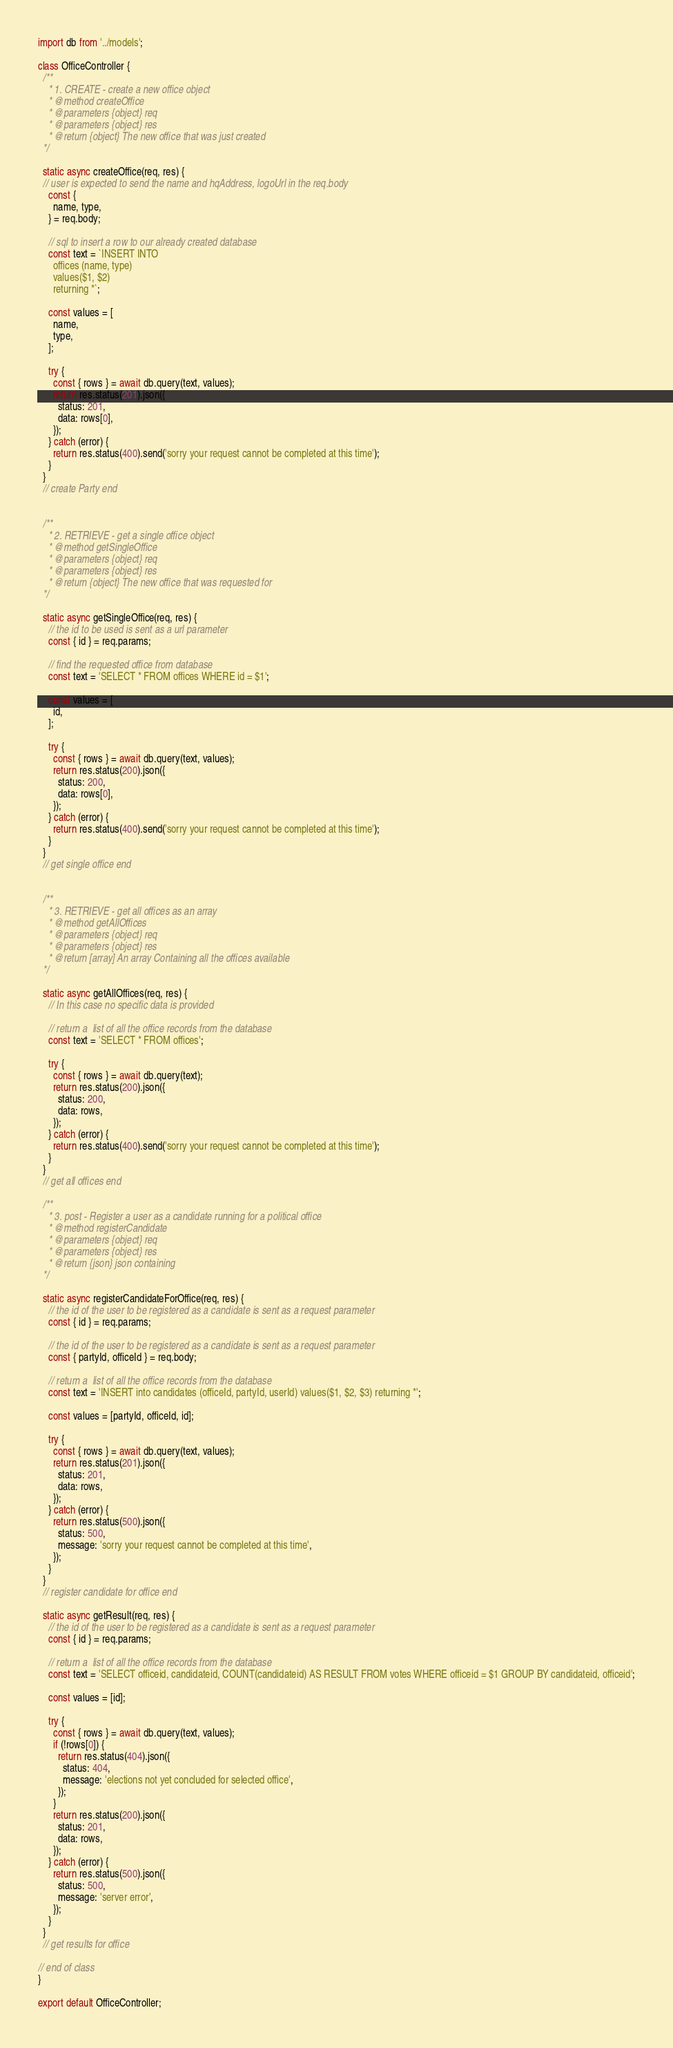Convert code to text. <code><loc_0><loc_0><loc_500><loc_500><_JavaScript_>import db from '../models';

class OfficeController {
  /**
    * 1. CREATE - create a new office object
    * @method createOffice
    * @parameters {object} req
    * @parameters {object} res
    * @return {object} The new office that was just created
  */

  static async createOffice(req, res) {
  // user is expected to send the name and hqAddress, logoUrl in the req.body
    const {
      name, type,
    } = req.body;

    // sql to insert a row to our already created database
    const text = `INSERT INTO
      offices (name, type)
      values($1, $2)
      returning *`;

    const values = [
      name,
      type,
    ];

    try {
      const { rows } = await db.query(text, values);
      return res.status(201).json({
        status: 201,
        data: rows[0],
      });
    } catch (error) {
      return res.status(400).send('sorry your request cannot be completed at this time');
    }
  }
  // create Party end


  /**
    * 2. RETRIEVE - get a single office object
    * @method getSingleOffice
    * @parameters {object} req
    * @parameters {object} res
    * @return {object} The new office that was requested for
  */

  static async getSingleOffice(req, res) {
    // the id to be used is sent as a url parameter
    const { id } = req.params;

    // find the requested office from database
    const text = 'SELECT * FROM offices WHERE id = $1';

    const values = [
      id,
    ];

    try {
      const { rows } = await db.query(text, values);
      return res.status(200).json({
        status: 200,
        data: rows[0],
      });
    } catch (error) {
      return res.status(400).send('sorry your request cannot be completed at this time');
    }
  }
  // get single office end


  /**
    * 3. RETRIEVE - get all offices as an array
    * @method getAllOffices
    * @parameters {object} req
    * @parameters {object} res
    * @return [array] An array Containing all the offices available
  */

  static async getAllOffices(req, res) {
    // In this case no specific data is provided

    // return a  list of all the office records from the database
    const text = 'SELECT * FROM offices';

    try {
      const { rows } = await db.query(text);
      return res.status(200).json({
        status: 200,
        data: rows,
      });
    } catch (error) {
      return res.status(400).send('sorry your request cannot be completed at this time');
    }
  }
  // get all offices end

  /**
    * 3. post - Register a user as a candidate running for a political office
    * @method registerCandidate
    * @parameters {object} req
    * @parameters {object} res
    * @return {json} json containing
  */

  static async registerCandidateForOffice(req, res) {
    // the id of the user to be registered as a candidate is sent as a request parameter
    const { id } = req.params;

    // the id of the user to be registered as a candidate is sent as a request parameter
    const { partyId, officeId } = req.body;

    // return a  list of all the office records from the database
    const text = 'INSERT into candidates (officeId, partyId, userId) values($1, $2, $3) returning *';

    const values = [partyId, officeId, id];

    try {
      const { rows } = await db.query(text, values);
      return res.status(201).json({
        status: 201,
        data: rows,
      });
    } catch (error) {
      return res.status(500).json({
        status: 500,
        message: 'sorry your request cannot be completed at this time',
      });
    }
  }
  // register candidate for office end

  static async getResult(req, res) {
    // the id of the user to be registered as a candidate is sent as a request parameter
    const { id } = req.params;

    // return a  list of all the office records from the database
    const text = 'SELECT officeid, candidateid, COUNT(candidateid) AS RESULT FROM votes WHERE officeid = $1 GROUP BY candidateid, officeid';

    const values = [id];

    try {
      const { rows } = await db.query(text, values);
      if (!rows[0]) {
        return res.status(404).json({
          status: 404,
          message: 'elections not yet concluded for selected office',
        });
      }
      return res.status(200).json({
        status: 201,
        data: rows,
      });
    } catch (error) {
      return res.status(500).json({
        status: 500,
        message: 'server error',
      });
    }
  }
  // get results for office

// end of class
}

export default OfficeController;
</code> 